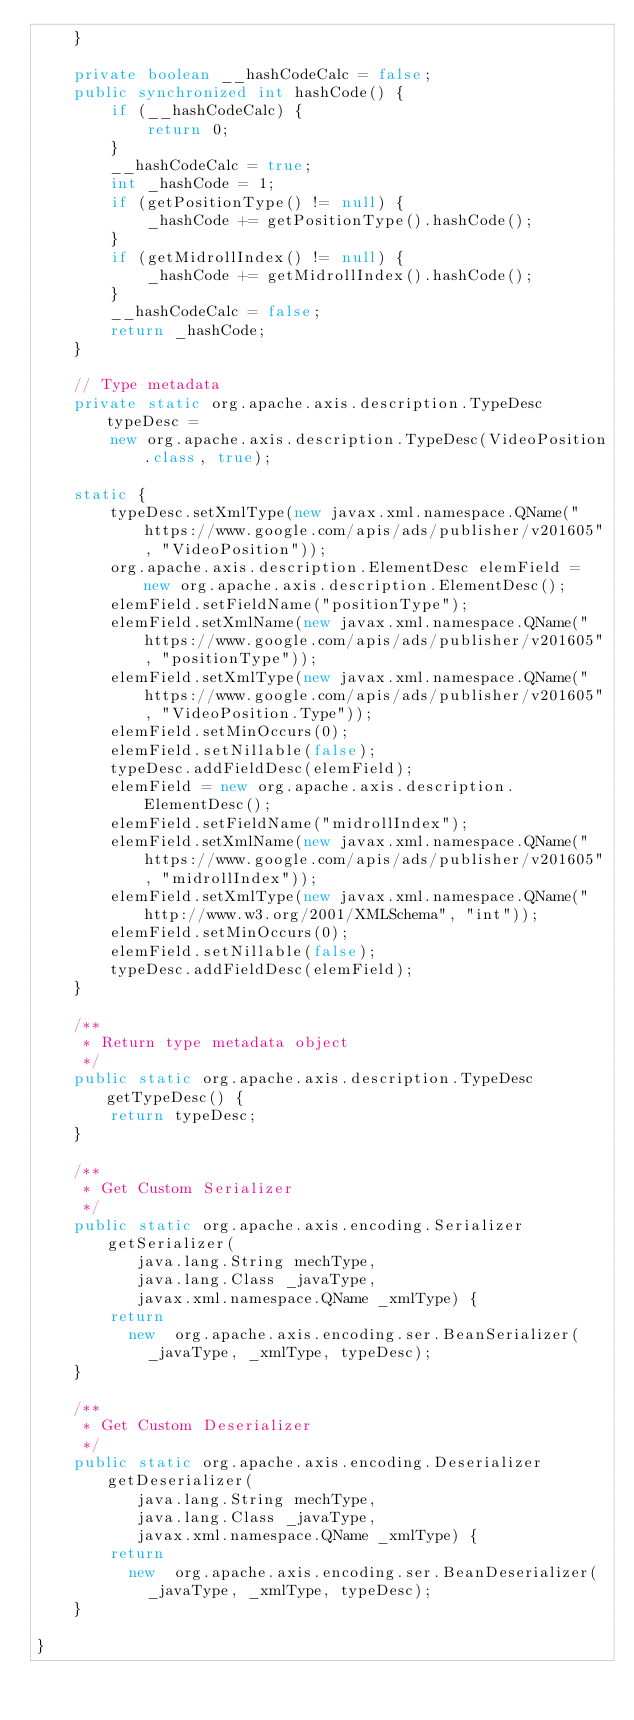Convert code to text. <code><loc_0><loc_0><loc_500><loc_500><_Java_>    }

    private boolean __hashCodeCalc = false;
    public synchronized int hashCode() {
        if (__hashCodeCalc) {
            return 0;
        }
        __hashCodeCalc = true;
        int _hashCode = 1;
        if (getPositionType() != null) {
            _hashCode += getPositionType().hashCode();
        }
        if (getMidrollIndex() != null) {
            _hashCode += getMidrollIndex().hashCode();
        }
        __hashCodeCalc = false;
        return _hashCode;
    }

    // Type metadata
    private static org.apache.axis.description.TypeDesc typeDesc =
        new org.apache.axis.description.TypeDesc(VideoPosition.class, true);

    static {
        typeDesc.setXmlType(new javax.xml.namespace.QName("https://www.google.com/apis/ads/publisher/v201605", "VideoPosition"));
        org.apache.axis.description.ElementDesc elemField = new org.apache.axis.description.ElementDesc();
        elemField.setFieldName("positionType");
        elemField.setXmlName(new javax.xml.namespace.QName("https://www.google.com/apis/ads/publisher/v201605", "positionType"));
        elemField.setXmlType(new javax.xml.namespace.QName("https://www.google.com/apis/ads/publisher/v201605", "VideoPosition.Type"));
        elemField.setMinOccurs(0);
        elemField.setNillable(false);
        typeDesc.addFieldDesc(elemField);
        elemField = new org.apache.axis.description.ElementDesc();
        elemField.setFieldName("midrollIndex");
        elemField.setXmlName(new javax.xml.namespace.QName("https://www.google.com/apis/ads/publisher/v201605", "midrollIndex"));
        elemField.setXmlType(new javax.xml.namespace.QName("http://www.w3.org/2001/XMLSchema", "int"));
        elemField.setMinOccurs(0);
        elemField.setNillable(false);
        typeDesc.addFieldDesc(elemField);
    }

    /**
     * Return type metadata object
     */
    public static org.apache.axis.description.TypeDesc getTypeDesc() {
        return typeDesc;
    }

    /**
     * Get Custom Serializer
     */
    public static org.apache.axis.encoding.Serializer getSerializer(
           java.lang.String mechType, 
           java.lang.Class _javaType,  
           javax.xml.namespace.QName _xmlType) {
        return 
          new  org.apache.axis.encoding.ser.BeanSerializer(
            _javaType, _xmlType, typeDesc);
    }

    /**
     * Get Custom Deserializer
     */
    public static org.apache.axis.encoding.Deserializer getDeserializer(
           java.lang.String mechType, 
           java.lang.Class _javaType,  
           javax.xml.namespace.QName _xmlType) {
        return 
          new  org.apache.axis.encoding.ser.BeanDeserializer(
            _javaType, _xmlType, typeDesc);
    }

}
</code> 